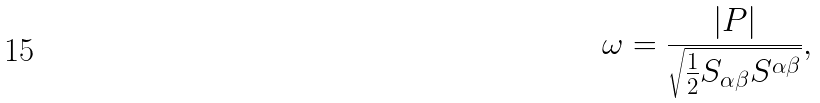<formula> <loc_0><loc_0><loc_500><loc_500>\omega = { \frac { | P | } { \sqrt { { \frac { 1 } { 2 } } S _ { \alpha \beta } S ^ { \alpha \beta } } } } ,</formula> 